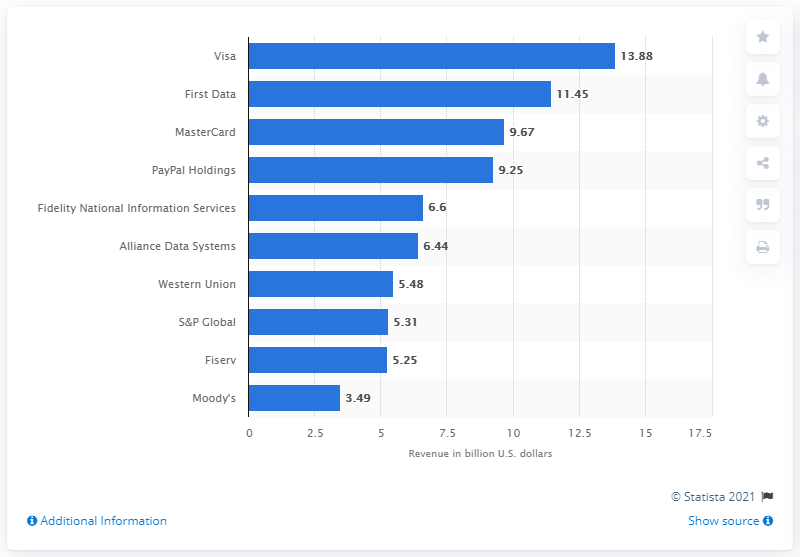Point out several critical features in this image. Visa's revenue in 2015 was 13.88 billion dollars. 